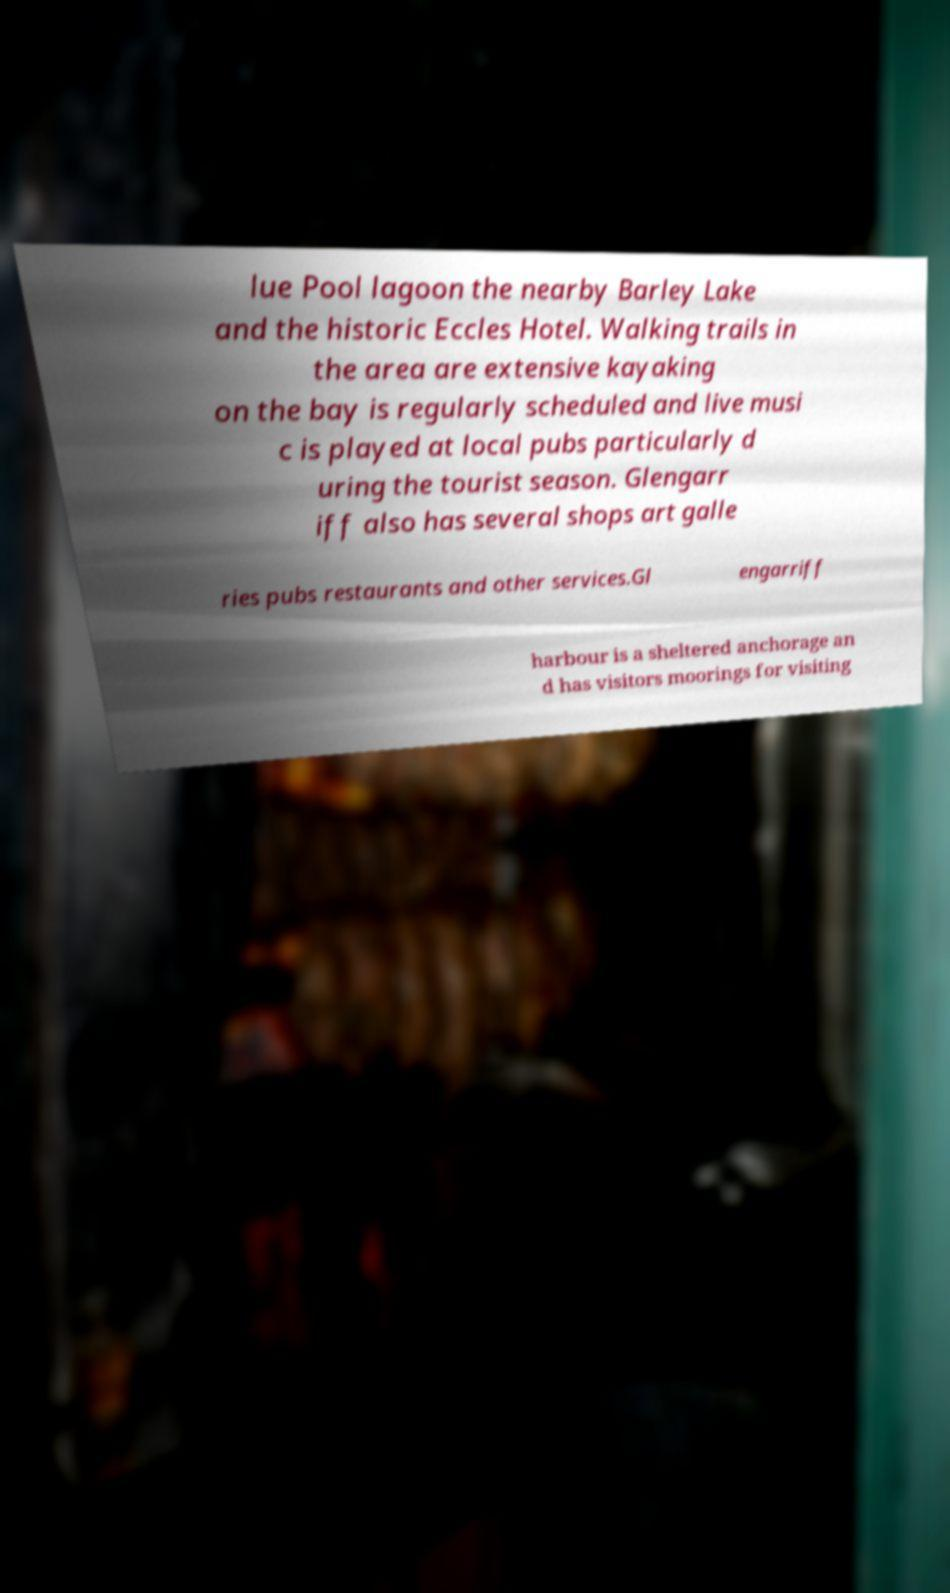Could you assist in decoding the text presented in this image and type it out clearly? lue Pool lagoon the nearby Barley Lake and the historic Eccles Hotel. Walking trails in the area are extensive kayaking on the bay is regularly scheduled and live musi c is played at local pubs particularly d uring the tourist season. Glengarr iff also has several shops art galle ries pubs restaurants and other services.Gl engarriff harbour is a sheltered anchorage an d has visitors moorings for visiting 